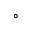<formula> <loc_0><loc_0><loc_500><loc_500>^ { \circ }</formula> 